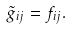Convert formula to latex. <formula><loc_0><loc_0><loc_500><loc_500>\tilde { g } _ { i j } = f _ { i j } .</formula> 